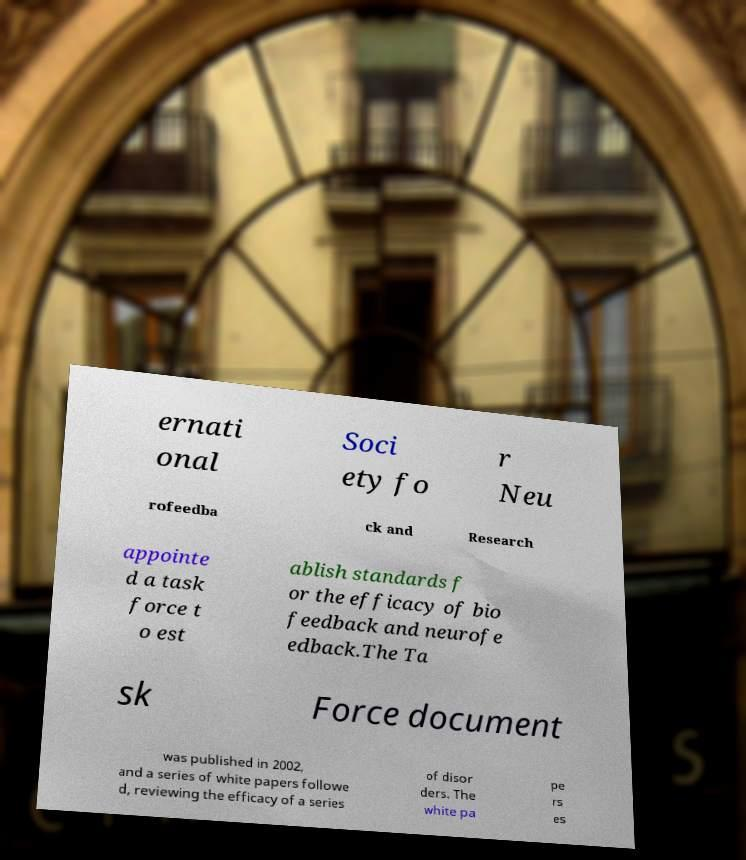Please identify and transcribe the text found in this image. ernati onal Soci ety fo r Neu rofeedba ck and Research appointe d a task force t o est ablish standards f or the efficacy of bio feedback and neurofe edback.The Ta sk Force document was published in 2002, and a series of white papers followe d, reviewing the efficacy of a series of disor ders. The white pa pe rs es 